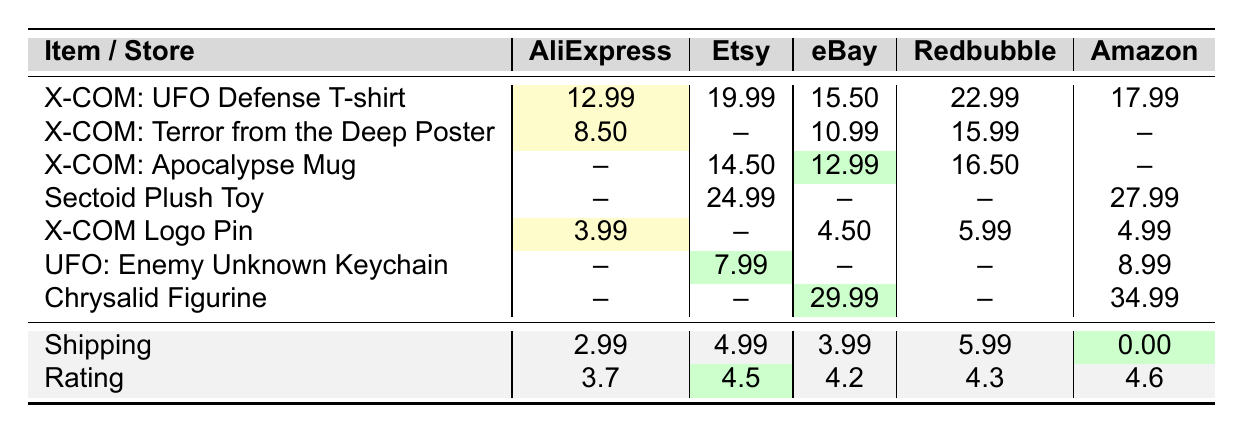What is the cheapest item available in AliExpress? The table shows that the cheapest item available in AliExpress is the "X-COM Logo Pin," priced at $3.99.
Answer: $3.99 Which store offers the "X-COM: Terror from the Deep Poster" at the lowest price? Looking at the prices, AliExpress offers the "X-COM: Terror from the Deep Poster" for $8.50, while other stores don't have this item listed or price is higher.
Answer: AliExpress How much will the total cost be for the "X-COM: Apocalypse Mug" from eBay, including shipping? The eBay price for the "X-COM: Apocalypse Mug" is $12.99, and the shipping cost is $3.99. Adding these gives a total of $12.99 + $3.99 = $16.98.
Answer: $16.98 Is the "Sectoid Plush Toy" cheaper on eBay or Amazon? On eBay, the "Sectoid Plush Toy" is not listed, while on Amazon it costs $27.99. Therefore, it is cheaper on Amazon, but eBay has no price for comparison.
Answer: Amazon What is the average price of the "X-COM: UFO Defense T-shirt" across all stores? The prices are 12.99 (AliExpress), 19.99 (Etsy), 15.50 (eBay), 22.99 (Redbubble), and 17.99 (Amazon). Adding these gives 12.99 + 19.99 + 15.50 + 22.99 + 17.99 = 89.46. Dividing by 5 gives an average of 89.46 / 5 = 17.892, which rounds to $17.89.
Answer: $17.89 Which store has the highest rating, and what is that rating? The ratings in the table show that Amazon has the highest rating at 4.6.
Answer: 4.6 How much more expensive is the "Chrysalid Figurine" on Amazon compared to eBay? The price for the "Chrysalid Figurine" is $34.99 on Amazon and $29.99 on eBay. The difference is $34.99 - $29.99 = $5.00.
Answer: $5.00 Is it true that all stores offer the "X-COM Logo Pin"? The table indicates that AliExpress, eBay, and Amazon offer the "X-COM Logo Pin," while Etsy and Redbubble do not have it listed. Therefore, it is false that all stores offer this item.
Answer: No Which item has the lowest shipping cost, and what is that cost? The shipping costs are: AliExpress $2.99, Etsy $4.99, eBay $3.99, Redbubble $5.99, and Amazon $0. The lowest shipping cost is $0 from Amazon.
Answer: $0 What is the total cost for the "UFO: Enemy Unknown Keychain" on Etsy including shipping? The price on Etsy for the "UFO: Enemy Unknown Keychain" is $7.99, and the shipping cost is $4.99. Adding these gives a total of $7.99 + $4.99 = $12.98.
Answer: $12.98 Which item has the highest listed price and what store is it found in? The "Chrysalid Figurine" is priced at $34.99 in Amazon, which is the highest listed price among all items.
Answer: $34.99, Amazon 